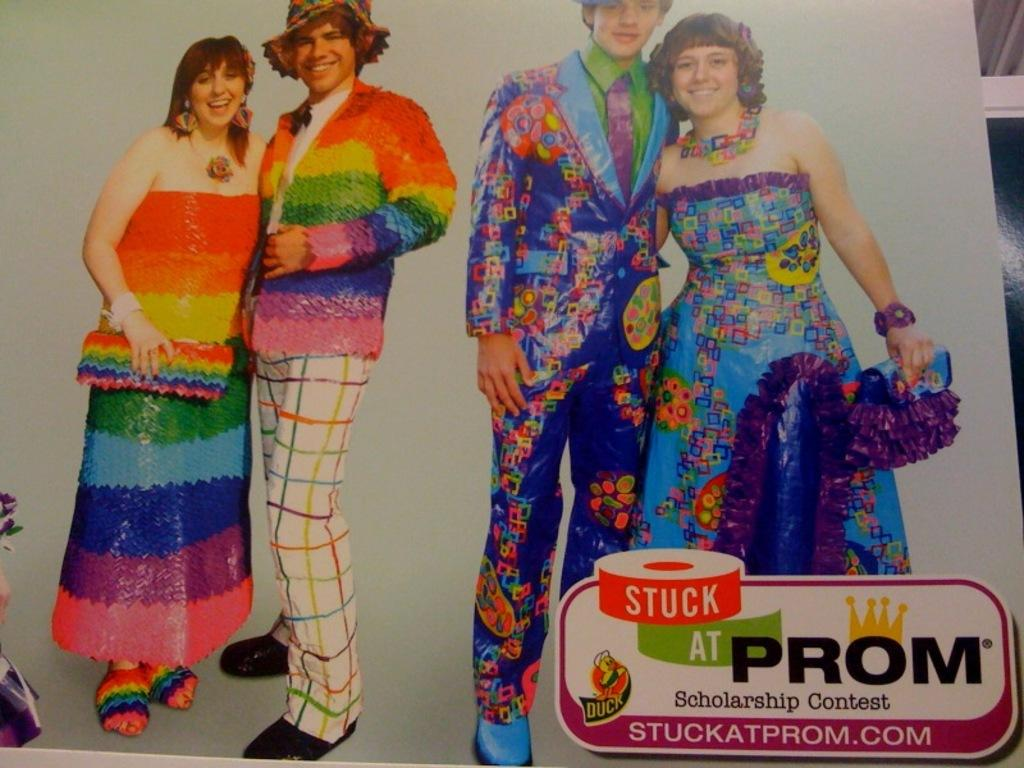What is the main object in the image? There is a hoarding in the image. What are the people in the image doing? Four persons are standing and smiling in the image. Where is the text located on the hoarding? The text is at the right bottom of the hoarding. What type of soda is being advertised on the hoarding? There is no soda being advertised on the hoarding; it only mentions the presence of four persons standing and smiling. How many books are visible on the hoarding? There are no books visible on the hoarding; it only features text and people. 